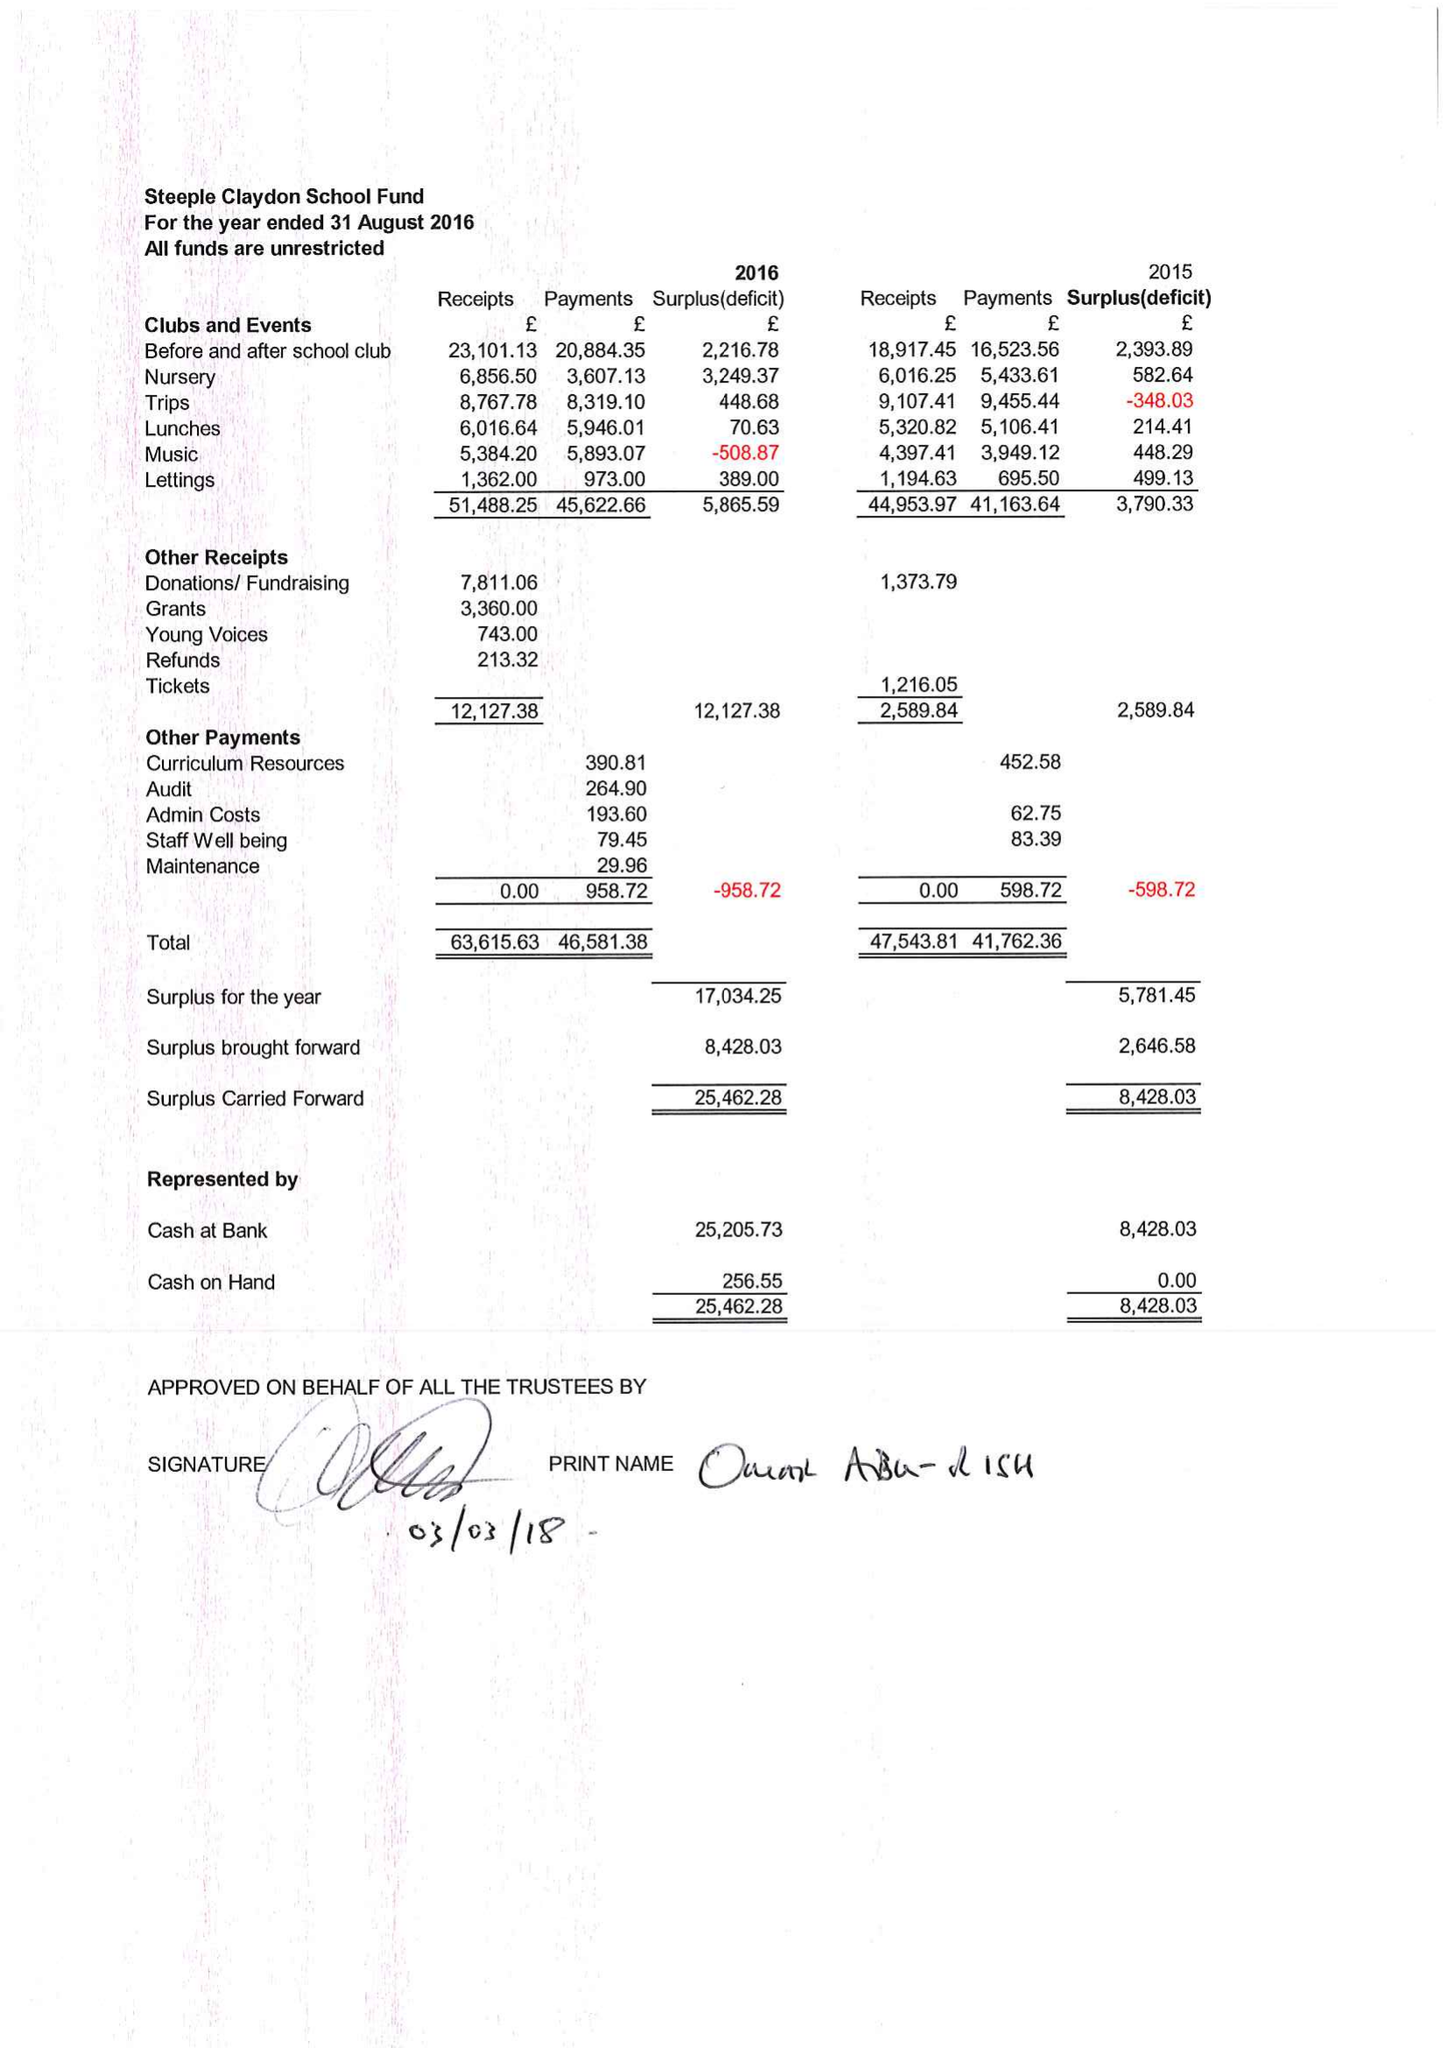What is the value for the income_annually_in_british_pounds?
Answer the question using a single word or phrase. 63616.00 